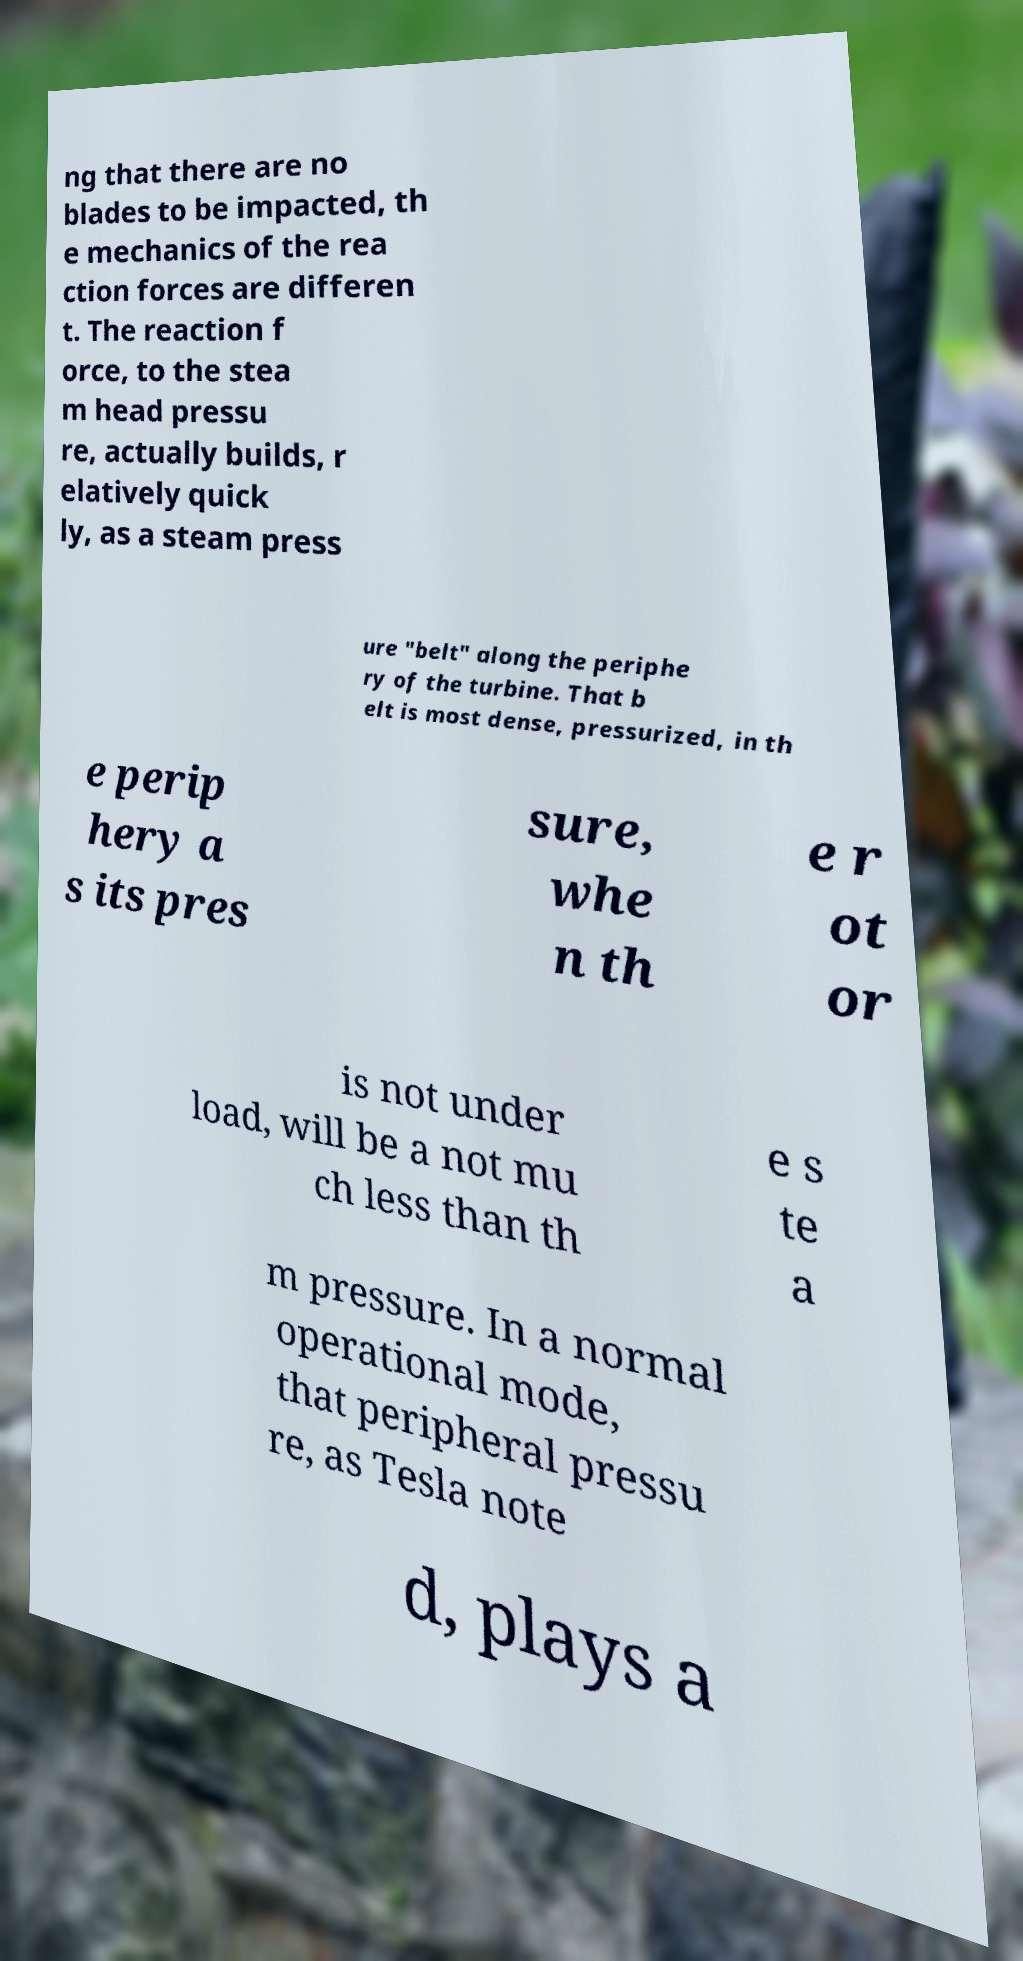Please read and relay the text visible in this image. What does it say? ng that there are no blades to be impacted, th e mechanics of the rea ction forces are differen t. The reaction f orce, to the stea m head pressu re, actually builds, r elatively quick ly, as a steam press ure "belt" along the periphe ry of the turbine. That b elt is most dense, pressurized, in th e perip hery a s its pres sure, whe n th e r ot or is not under load, will be a not mu ch less than th e s te a m pressure. In a normal operational mode, that peripheral pressu re, as Tesla note d, plays a 